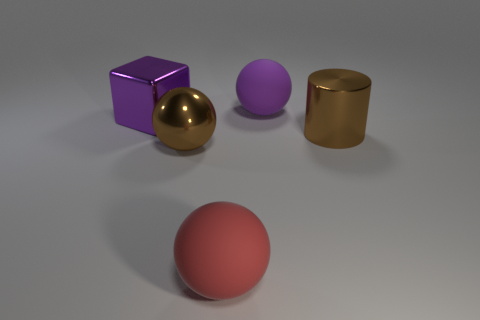Subtract 1 balls. How many balls are left? 2 Add 3 cylinders. How many objects exist? 8 Subtract all rubber spheres. How many spheres are left? 1 Subtract all cylinders. How many objects are left? 4 Subtract all tiny matte balls. Subtract all rubber things. How many objects are left? 3 Add 4 large purple metallic objects. How many large purple metallic objects are left? 5 Add 1 tiny brown matte objects. How many tiny brown matte objects exist? 1 Subtract 0 brown cubes. How many objects are left? 5 